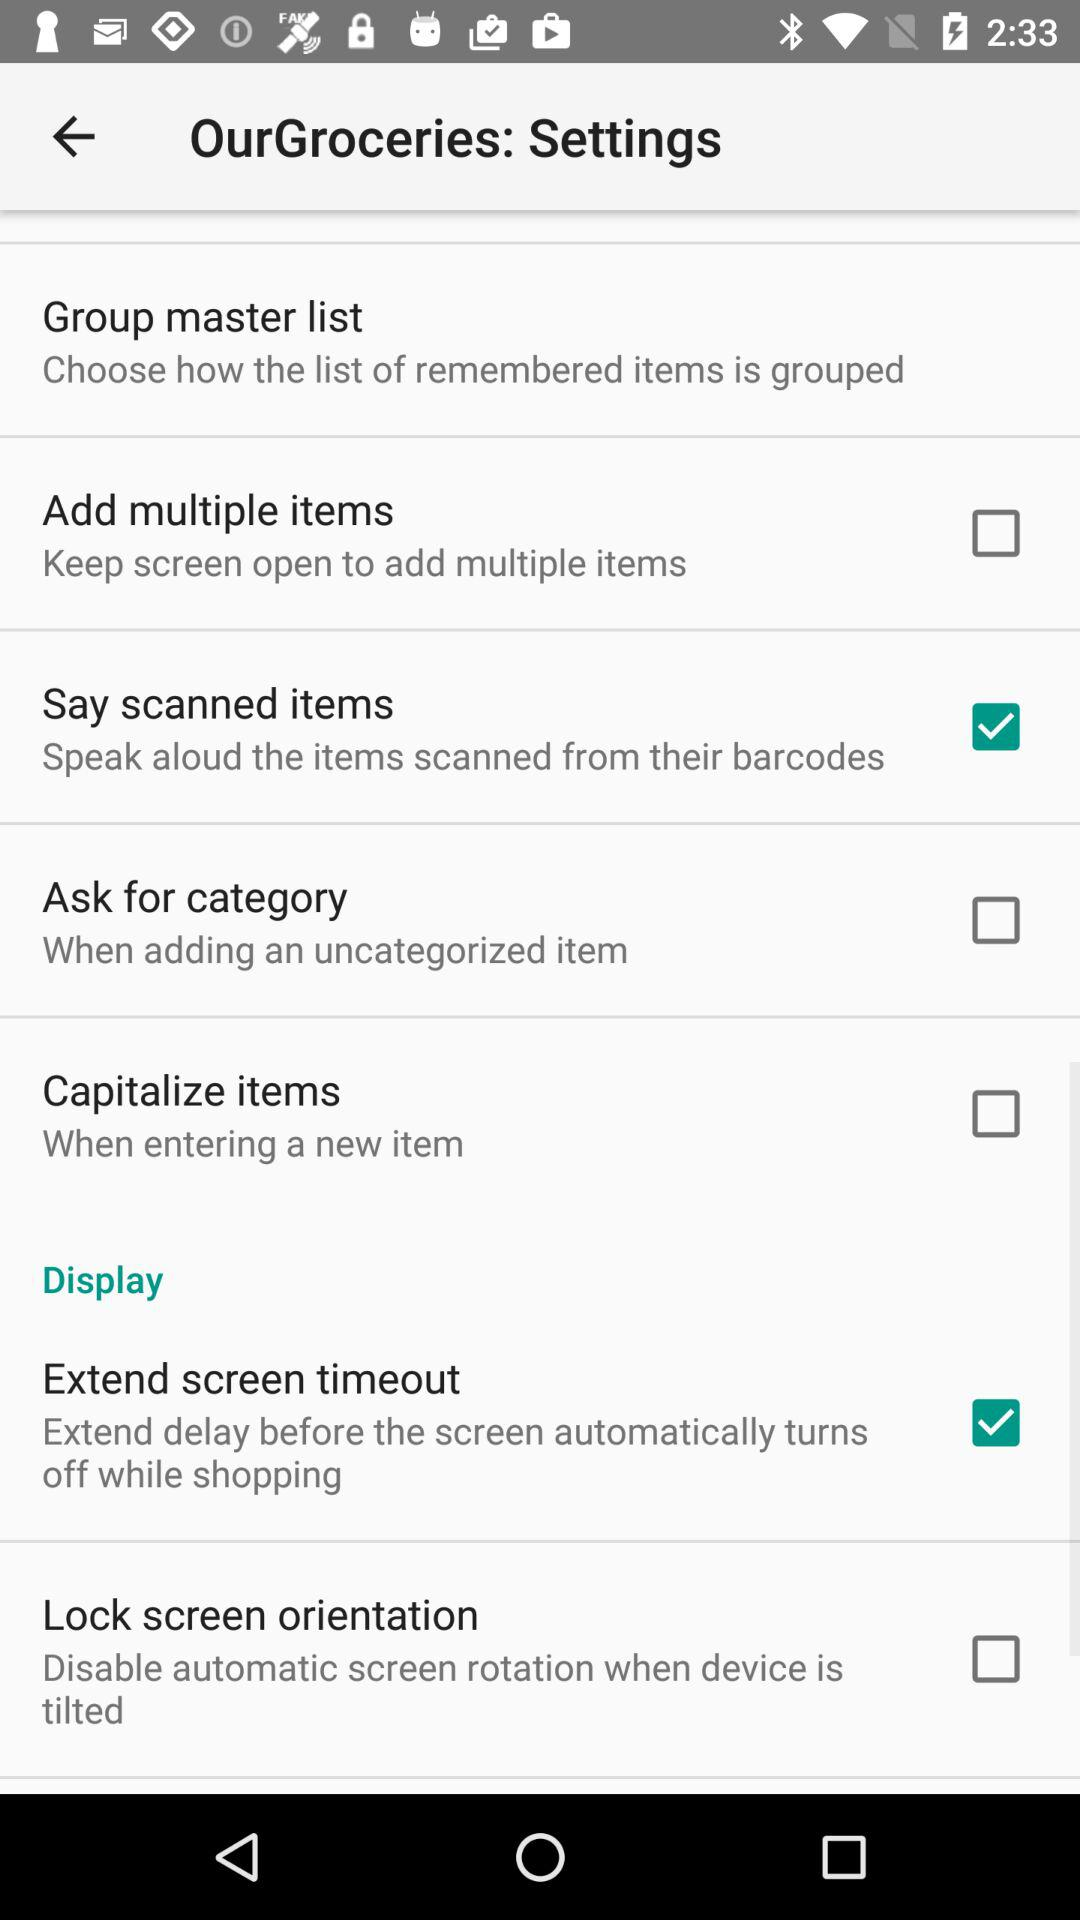What are the "Display" settings? The "Display" settings are "Extend screen timeout" and "Lock screen orientation". 